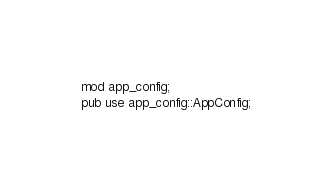Convert code to text. <code><loc_0><loc_0><loc_500><loc_500><_Rust_>mod app_config;
pub use app_config::AppConfig;
</code> 